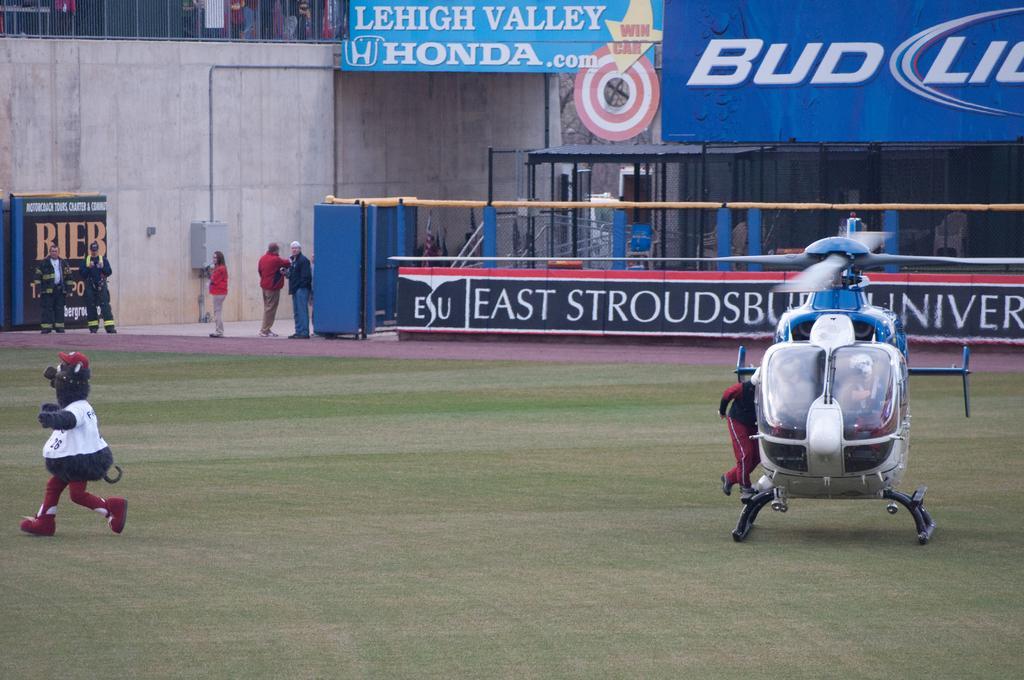How would you summarize this image in a sentence or two? In this image we can see man with costumes, persons, helicopter on the grass. In the background we can see persons, advertisements, pillars, shed and wall. 